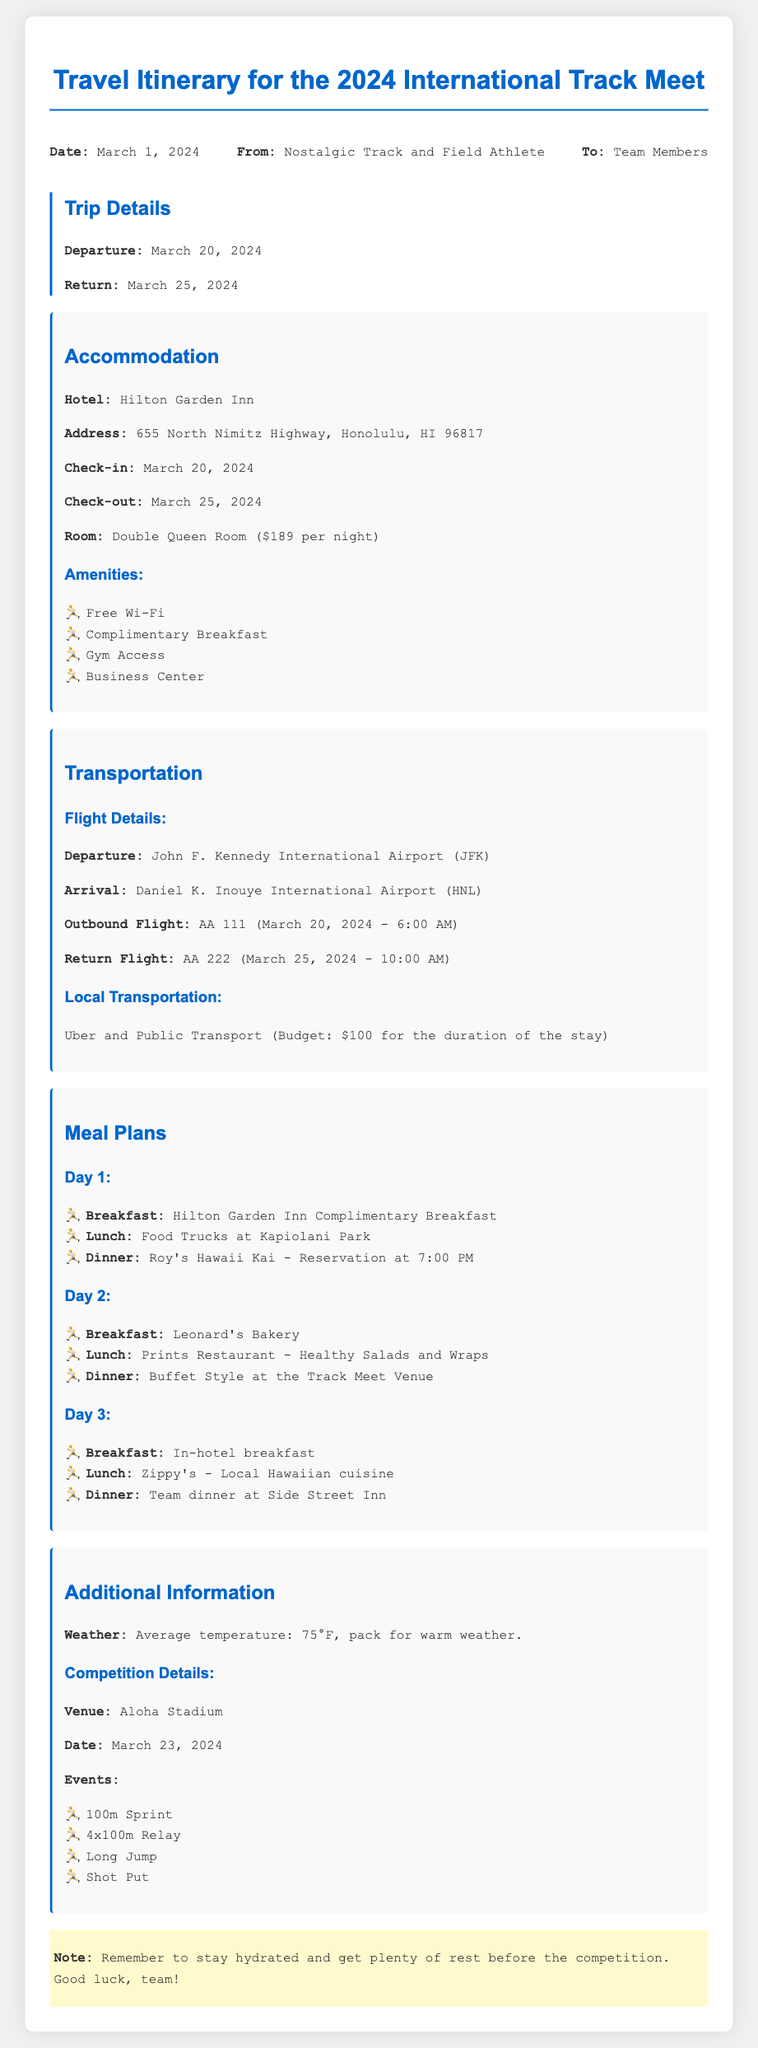What is the departure date? The departure date is specified in the Trip Details section of the document as March 20, 2024.
Answer: March 20, 2024 What is the name of the hotel? The hotel name is mentioned in the Accommodation section of the document as Hilton Garden Inn.
Answer: Hilton Garden Inn What is the budget for local transportation? The budget for local transportation is stated in the Transportation section as $100 for the duration of the stay.
Answer: $100 What is the check-out date? The check-out date is provided in the Accommodation section and is March 25, 2024.
Answer: March 25, 2024 How many nights will the team stay at the hotel? To determine the number of nights, we calculate from the check-in date (March 20) to the check-out date (March 25), which is 5 nights.
Answer: 5 nights What meal is planned for Day 1 dinner? The meal plan for Day 1 dinner is specified in the Meal Plans section as a reservation at Roy's Hawaii Kai at 7:00 PM.
Answer: Roy's Hawaii Kai - Reservation at 7:00 PM What is the average temperature mentioned for the weather? The average temperature is noted in the Additional Information section as 75°F.
Answer: 75°F Which venue is hosting the competition? The competition venue is indicated in the Additional Information section and is Aloha Stadium.
Answer: Aloha Stadium What kind of room is booked for accommodation? The type of room is specified in the Accommodation section as a Double Queen Room.
Answer: Double Queen Room 